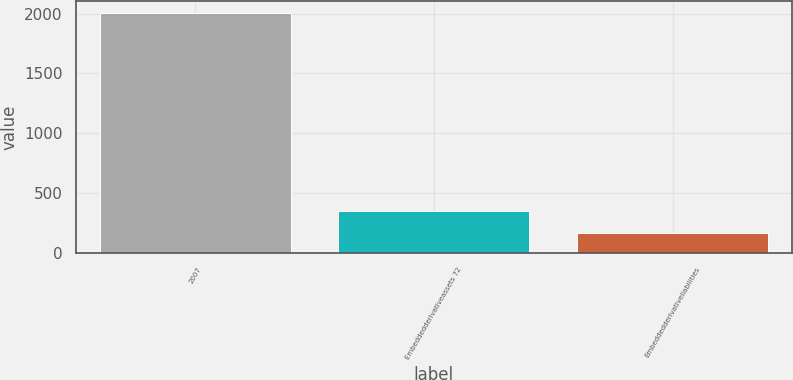Convert chart. <chart><loc_0><loc_0><loc_500><loc_500><bar_chart><fcel>2007<fcel>Embeddedderivativeassets 72<fcel>Embeddedderivativeliabilities<nl><fcel>2006<fcel>352.7<fcel>169<nl></chart> 